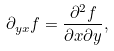<formula> <loc_0><loc_0><loc_500><loc_500>\partial _ { y x } f = { \frac { \partial ^ { 2 } f } { \partial x \partial y } } ,</formula> 